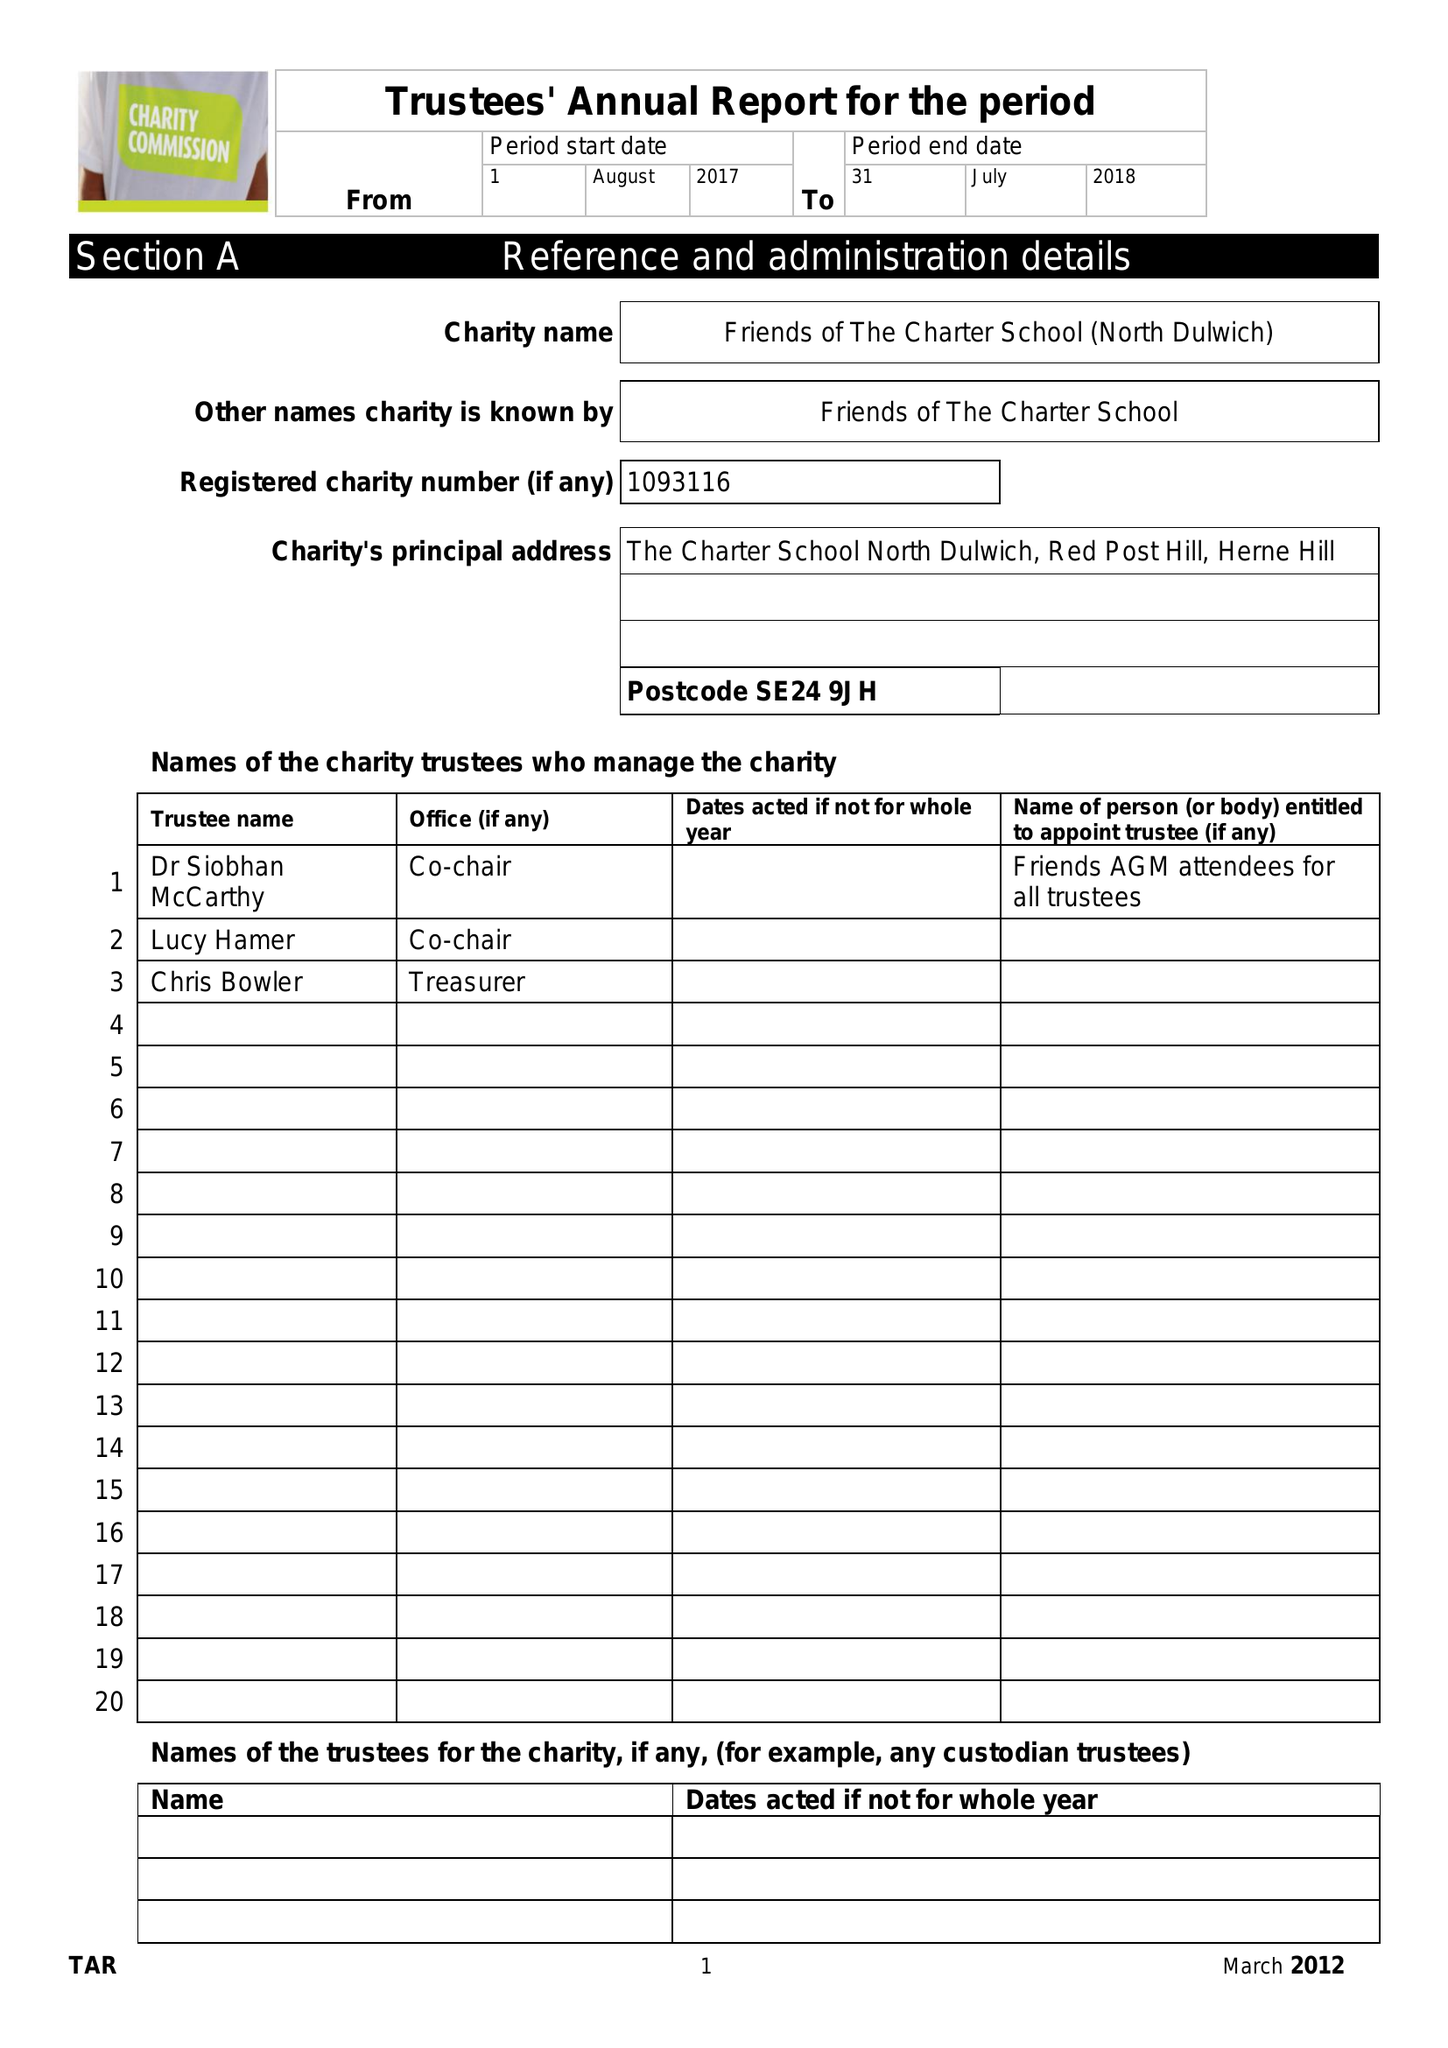What is the value for the address__post_town?
Answer the question using a single word or phrase. LONDON 